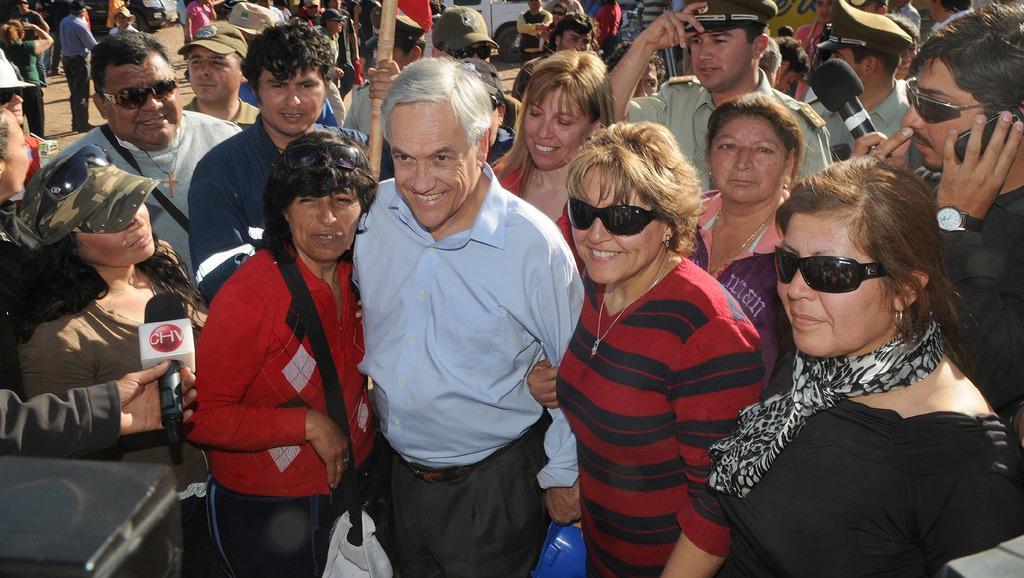Can you describe this image briefly? In this image there are few people on the road in which two of them are holding microphones. 